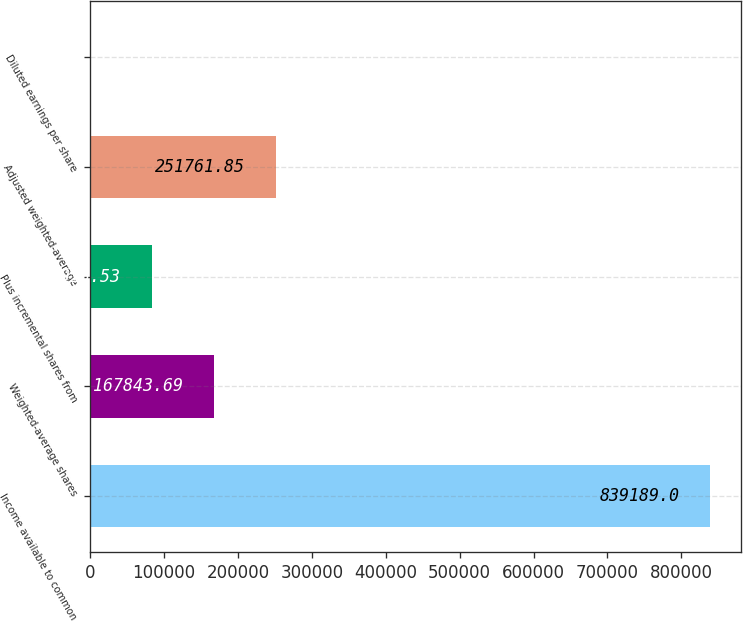Convert chart to OTSL. <chart><loc_0><loc_0><loc_500><loc_500><bar_chart><fcel>Income available to common<fcel>Weighted-average shares<fcel>Plus incremental shares from<fcel>Adjusted weighted-average<fcel>Diluted earnings per share<nl><fcel>839189<fcel>167844<fcel>83925.5<fcel>251762<fcel>7.37<nl></chart> 